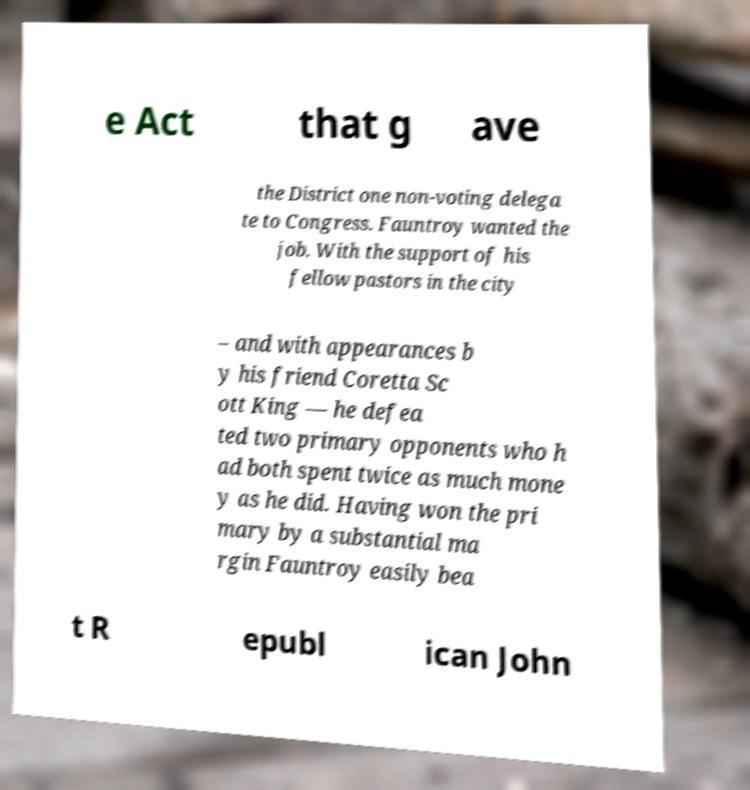Can you accurately transcribe the text from the provided image for me? e Act that g ave the District one non-voting delega te to Congress. Fauntroy wanted the job. With the support of his fellow pastors in the city – and with appearances b y his friend Coretta Sc ott King — he defea ted two primary opponents who h ad both spent twice as much mone y as he did. Having won the pri mary by a substantial ma rgin Fauntroy easily bea t R epubl ican John 